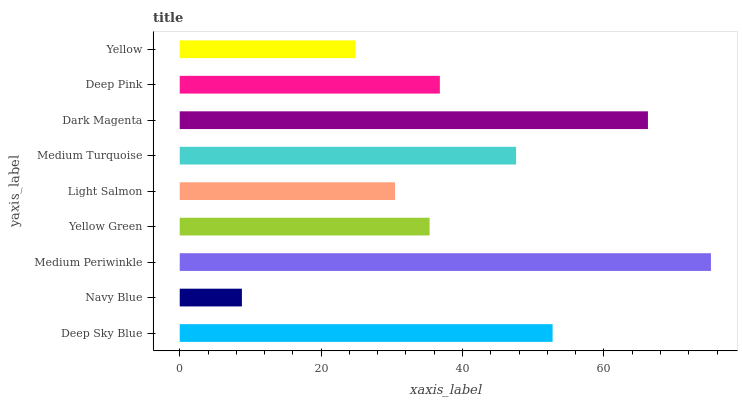Is Navy Blue the minimum?
Answer yes or no. Yes. Is Medium Periwinkle the maximum?
Answer yes or no. Yes. Is Medium Periwinkle the minimum?
Answer yes or no. No. Is Navy Blue the maximum?
Answer yes or no. No. Is Medium Periwinkle greater than Navy Blue?
Answer yes or no. Yes. Is Navy Blue less than Medium Periwinkle?
Answer yes or no. Yes. Is Navy Blue greater than Medium Periwinkle?
Answer yes or no. No. Is Medium Periwinkle less than Navy Blue?
Answer yes or no. No. Is Deep Pink the high median?
Answer yes or no. Yes. Is Deep Pink the low median?
Answer yes or no. Yes. Is Deep Sky Blue the high median?
Answer yes or no. No. Is Light Salmon the low median?
Answer yes or no. No. 